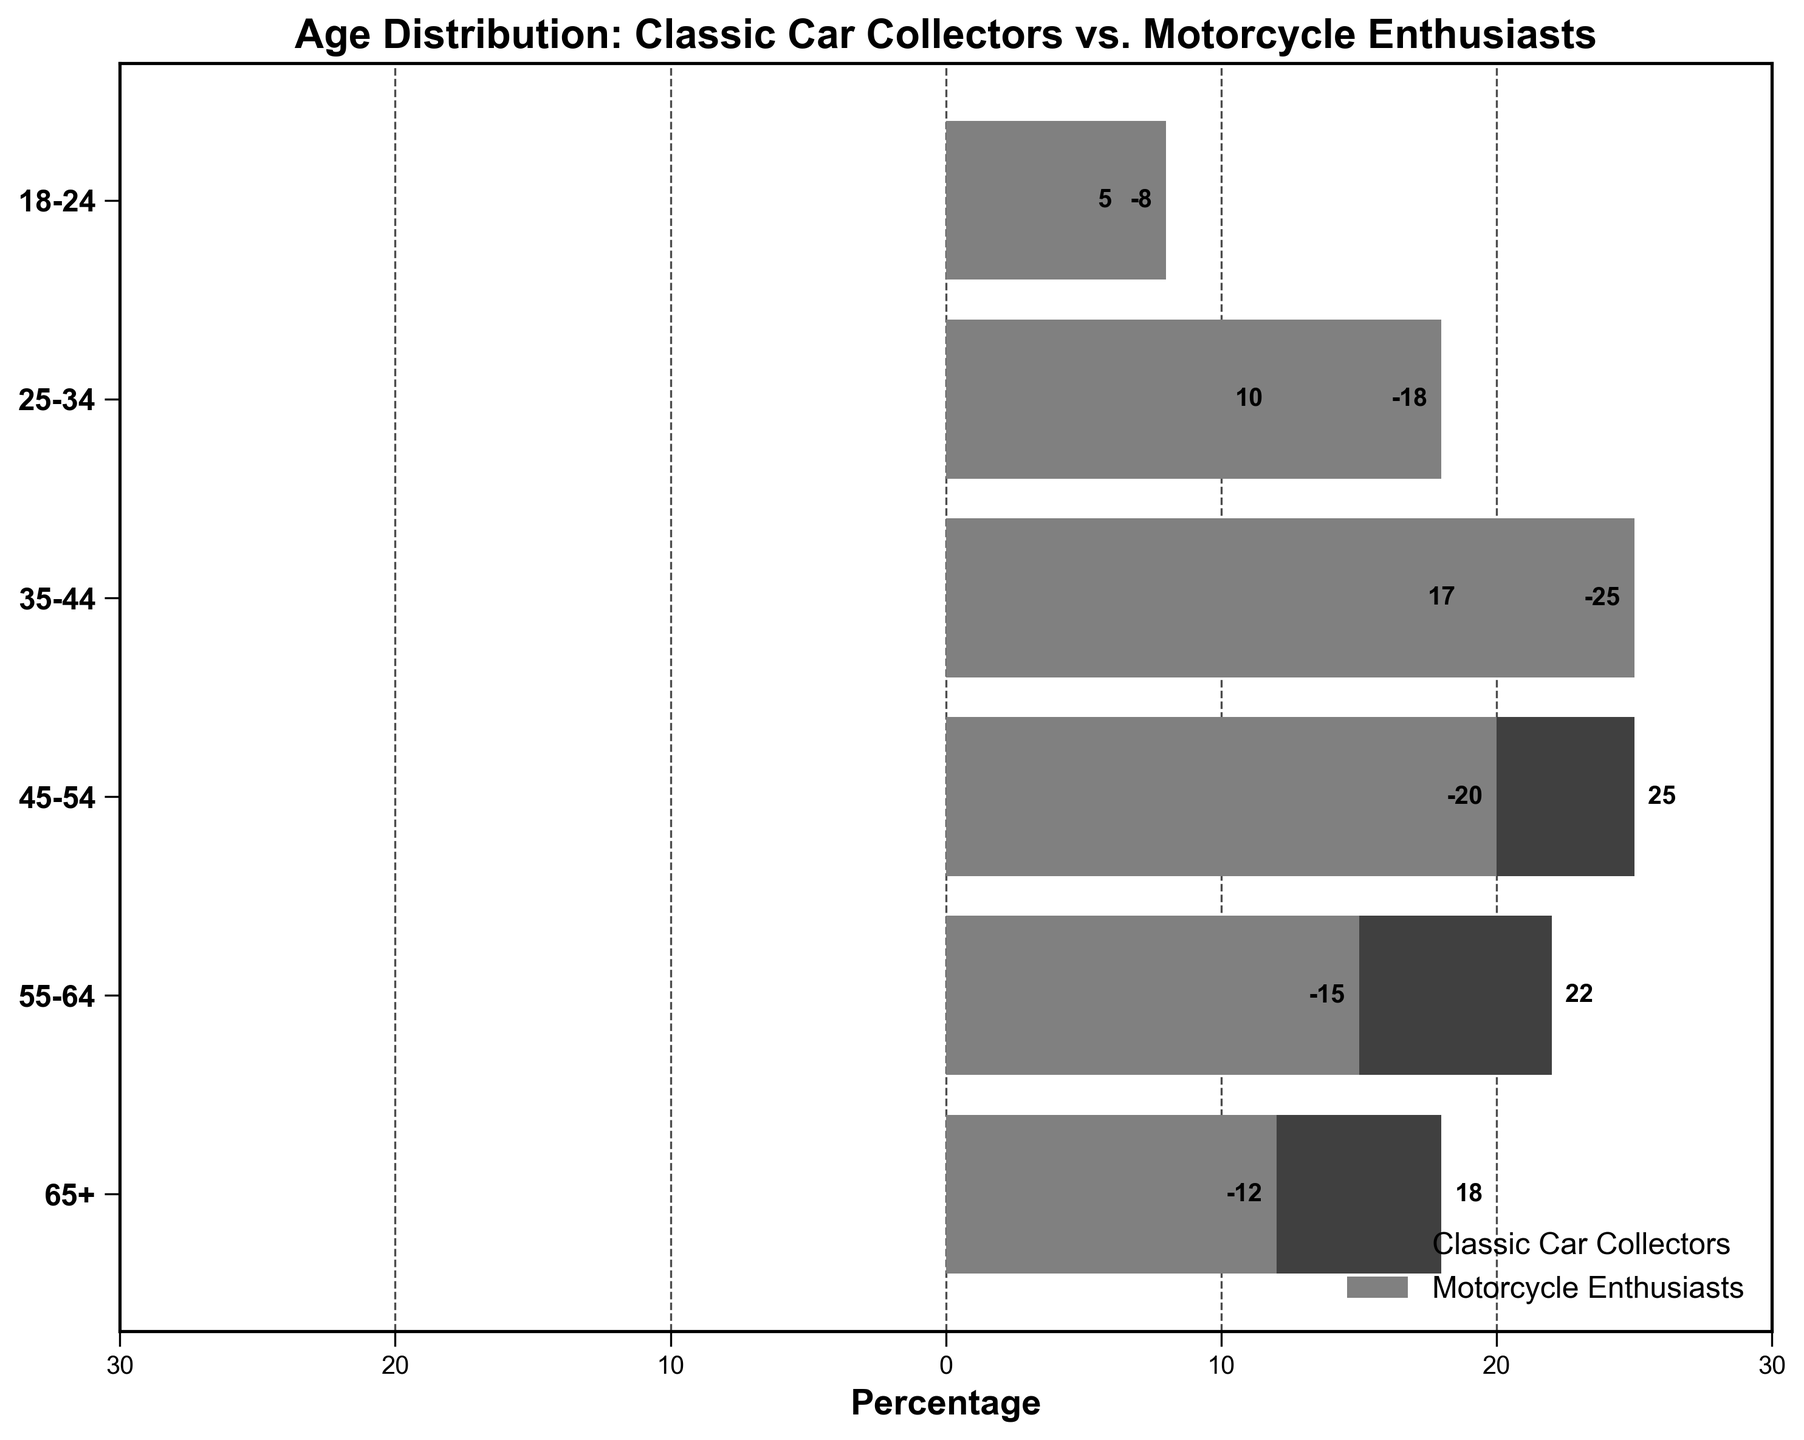What is the title of the figure? The title of the figure is displayed at the top and usually summarizes what the chart is about. Here, the title is visible.
Answer: Age Distribution: Classic Car Collectors vs. Motorcycle Enthusiasts How many age groups are represented in the figure? Count the number of unique age groups listed on the y-axis. There are six age groups shown.
Answer: 6 Which age group has the highest percentage of classic car collectors? Look for the bar with the highest value on the right side of the figure. The age group 45-54 shows the highest percentage.
Answer: 45-54 In the age group 18-24, which group has more participants? Compare the bar lengths for the 18-24 age group on both sides of the chart. The bar for classic car collectors (5%) is longer than for motorcycle enthusiasts (8%).
Answer: Classic Car Collectors What is the total percentage of motorcycle enthusiasts for the age groups 35-44 and 25-34 combined? Add the percentages of motorcycle enthusiasts for age groups 35-44 and 25-34. The sum is 25 (from 35-44) + 18 (from 25-34).
Answer: 43 What is the difference in percentage between classic car collectors and motorcycle enthusiasts in the 55-64 age group? Subtract the percentage of motorcycle enthusiasts from the percentage of classic car collectors in the 55-64 age group. The difference is 22 (car collectors) - 15 (motorcycle enthusiasts).
Answer: 7 Which side has the higher total percentage summed across all age groups, classic car collectors or motorcycle enthusiasts? Sum the percentages for each group and compare. Car Collectors: 18+22+25+17+10+5 = 97, Motorcycle Enthusiasts: 12+15+20+25+18+8 = 98. Motorcycle Enthusiasts have a higher total percentage.
Answer: Motorcycle Enthusiasts What is the percentage of classic car collectors in the 65+ age group compared to the percentage of motorcycle enthusiasts in the same group? Check the bar lengths for the 65+ age group for both collectors and enthusiasts. For classic car collectors, it's 18%; for motorcycle enthusiasts, it's 12%. Compare these values.
Answer: Classic Car Collectors: 18%, Motorcycle Enthusiasts: 12% How does the age distribution of classic car collectors compare to that of motorcycle enthusiasts across the board? Examine the overall patterns of the bars. Classic car collectors show a peak around middle age (45-54), whereas motorcycle enthusiasts peak earlier (35-44).
Answer: Classic car collectors peak at 45-54, motorcycle enthusiasts at 35-44 Which age group has the smallest difference in percentages between the two groups? Calculate the differences for each age group, and find the smallest one. For age groups under consideration: 18-24 (3), 25-34 (8), 35-44 (8), 45-54 (5), 55-64 (7), 65+ (6). The smallest difference is for 18-24 age group.
Answer: 18-24 